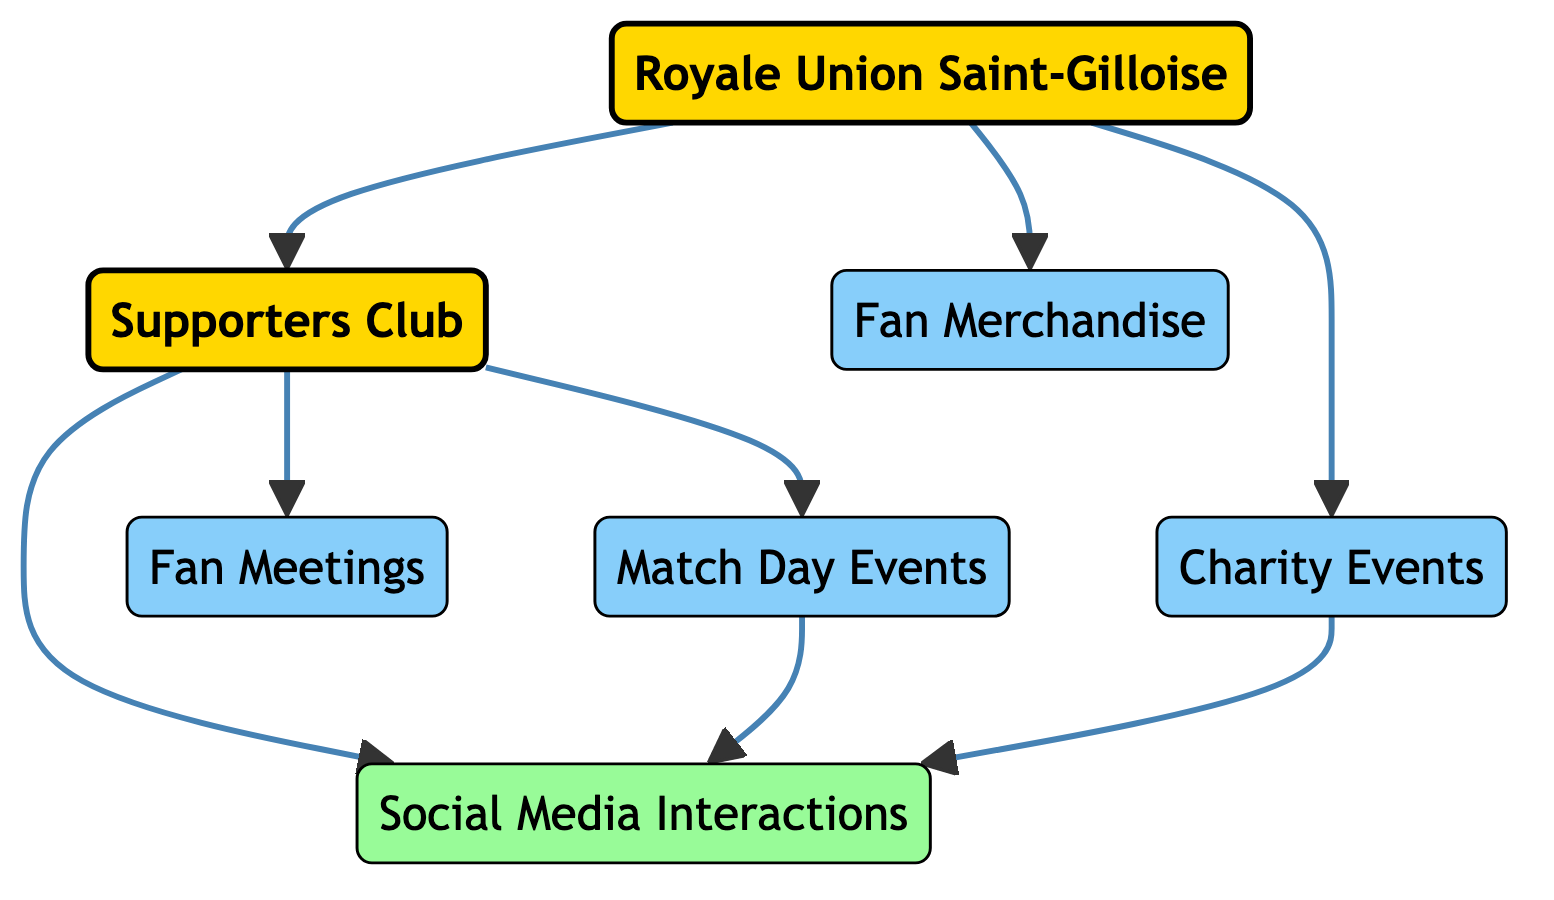What is the total number of nodes in the diagram? There are six nodes represented in the diagram: Royale Union Saint-Gilloise, Supporters Club, Match Day Events, Fan Meetings, Charity Events, and Fan Merchandise.
Answer: 6 How many edges are there connecting the nodes? The diagram has eight edges showing the relationships between the nodes. Each edge represents a directed connection from one node to another.
Answer: 8 Which node is directly connected to the Supporters Club? The Supporters Club is directly connected to Match Day Events, Fan Meetings, and Social Media Interactions, implying that it plays a significant role in fan engagement activities.
Answer: Match Day Events, Fan Meetings, Social Media Interactions From which node do the Charity Events stem? The Charity Events stem directly from Royale Union Saint-Gilloise, indicating that these events are organized or endorsed by the club itself.
Answer: Royale Union Saint-Gilloise What type of interactions occur from the Match Day Events node? The Match Day Events node directs to Social Media Interactions, implying that these events have a significant online presence and interactions.
Answer: Social Media Interactions What role does the Supporters Club play in the diagram? The Supporters Club acts as a pivotal intermediary, connecting to Match Day Events, Fan Meetings, and Social Media Interactions while linking to the Royale Union Saint-Gilloise.
Answer: Intermediary How do Charity Events relate to Social Media? Charity Events directly link to Social Media Interactions in the diagram, suggesting that these events are promoted or discussed through social media platforms.
Answer: Directly link Which node does Fan Merchandise originate from? Fan Merchandise is directly connected to Royale Union Saint-Gilloise, showing that the club provides or supports the sale of merchandise for fans.
Answer: Royale Union Saint-Gilloise 